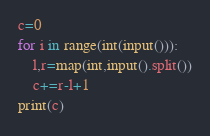Convert code to text. <code><loc_0><loc_0><loc_500><loc_500><_Python_>c=0
for i in range(int(input())):
    l,r=map(int,input().split())
    c+=r-l+1
print(c)</code> 